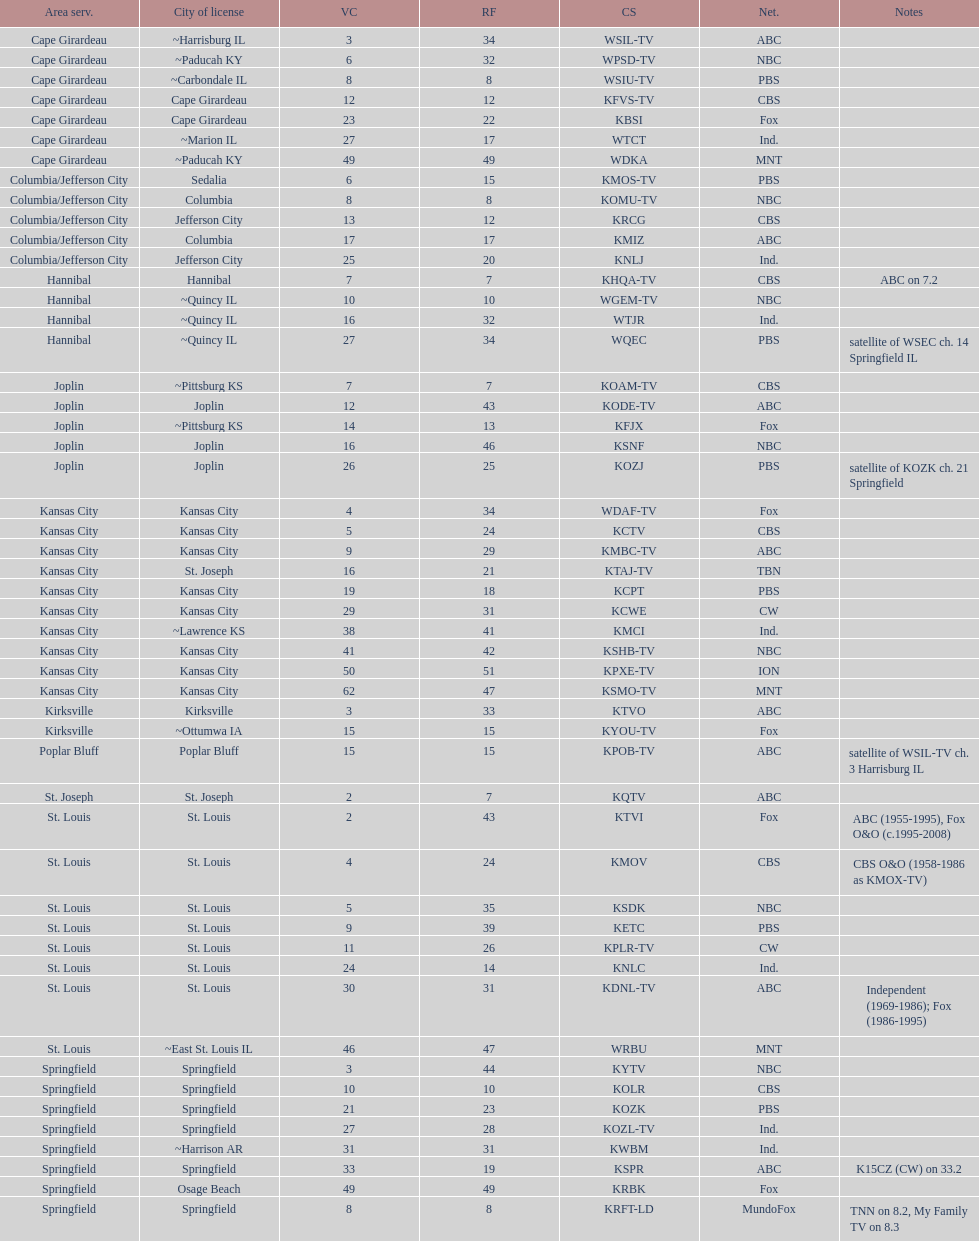How many of these missouri tv stations are actually licensed in a city in illinois (il)? 7. 